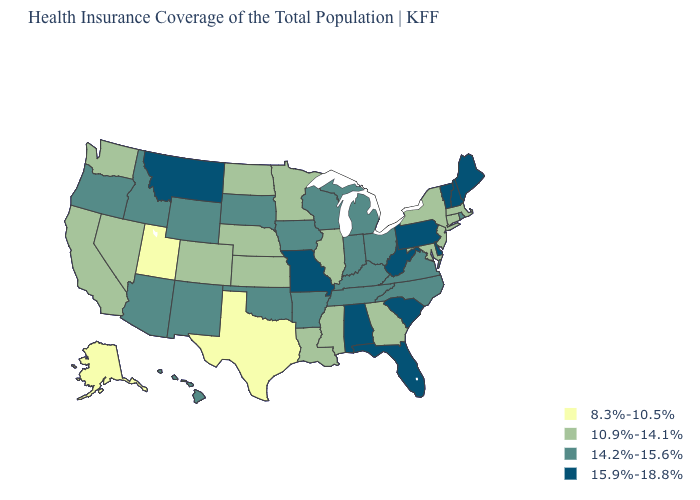What is the value of Mississippi?
Keep it brief. 10.9%-14.1%. Does the map have missing data?
Answer briefly. No. What is the value of Nebraska?
Quick response, please. 10.9%-14.1%. Does the map have missing data?
Answer briefly. No. Among the states that border Tennessee , does Missouri have the highest value?
Write a very short answer. Yes. Which states have the lowest value in the USA?
Give a very brief answer. Alaska, Texas, Utah. What is the value of Pennsylvania?
Concise answer only. 15.9%-18.8%. What is the value of Missouri?
Keep it brief. 15.9%-18.8%. What is the value of West Virginia?
Quick response, please. 15.9%-18.8%. Does Oklahoma have the lowest value in the South?
Write a very short answer. No. Among the states that border Massachusetts , does New Hampshire have the highest value?
Concise answer only. Yes. Does Pennsylvania have a higher value than West Virginia?
Give a very brief answer. No. What is the value of Massachusetts?
Keep it brief. 10.9%-14.1%. What is the value of Indiana?
Keep it brief. 14.2%-15.6%. What is the lowest value in the USA?
Concise answer only. 8.3%-10.5%. 